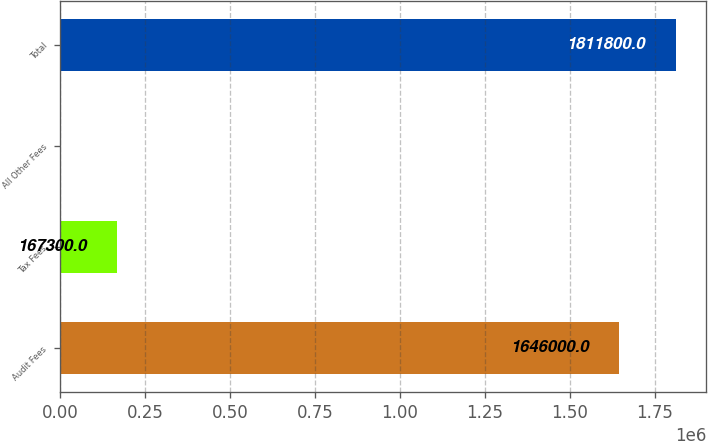<chart> <loc_0><loc_0><loc_500><loc_500><bar_chart><fcel>Audit Fees<fcel>Tax Fees<fcel>All Other Fees<fcel>Total<nl><fcel>1.646e+06<fcel>167300<fcel>1500<fcel>1.8118e+06<nl></chart> 